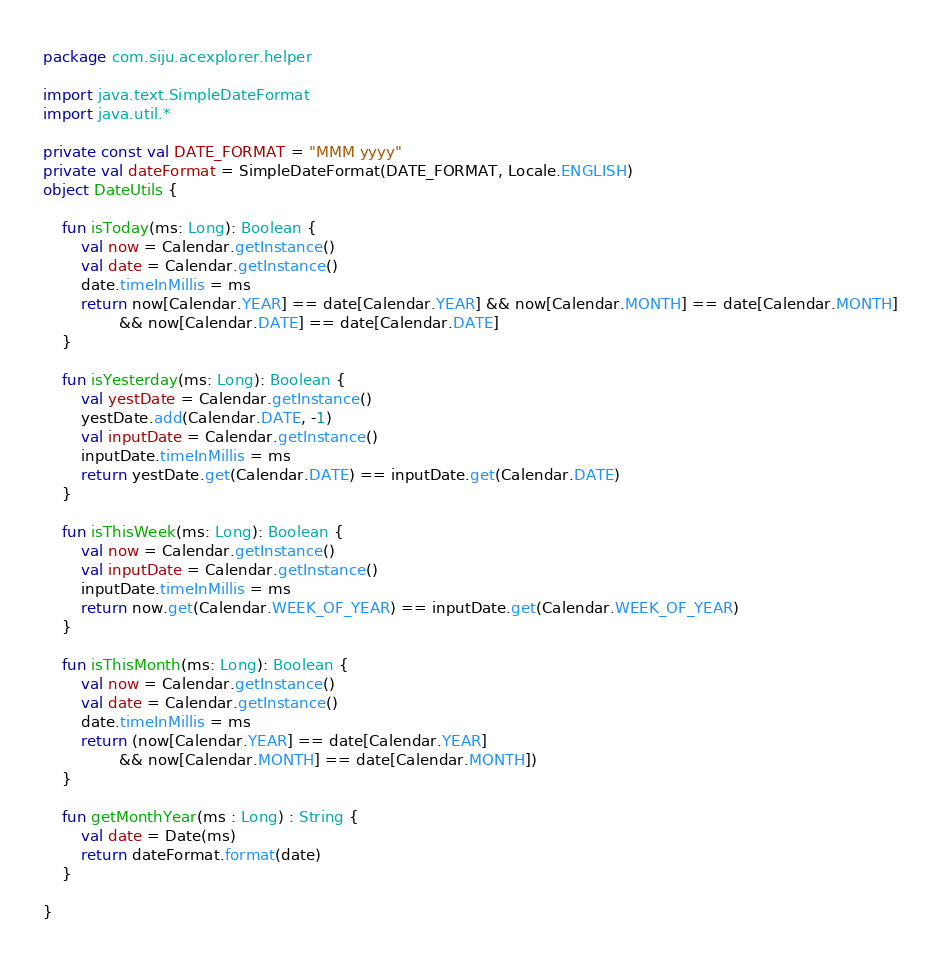<code> <loc_0><loc_0><loc_500><loc_500><_Kotlin_>package com.siju.acexplorer.helper

import java.text.SimpleDateFormat
import java.util.*

private const val DATE_FORMAT = "MMM yyyy"
private val dateFormat = SimpleDateFormat(DATE_FORMAT, Locale.ENGLISH)
object DateUtils {

    fun isToday(ms: Long): Boolean {
        val now = Calendar.getInstance()
        val date = Calendar.getInstance()
        date.timeInMillis = ms
        return now[Calendar.YEAR] == date[Calendar.YEAR] && now[Calendar.MONTH] == date[Calendar.MONTH]
                && now[Calendar.DATE] == date[Calendar.DATE]
    }

    fun isYesterday(ms: Long): Boolean {
        val yestDate = Calendar.getInstance()
        yestDate.add(Calendar.DATE, -1)
        val inputDate = Calendar.getInstance()
        inputDate.timeInMillis = ms
        return yestDate.get(Calendar.DATE) == inputDate.get(Calendar.DATE)
    }

    fun isThisWeek(ms: Long): Boolean {
        val now = Calendar.getInstance()
        val inputDate = Calendar.getInstance()
        inputDate.timeInMillis = ms
        return now.get(Calendar.WEEK_OF_YEAR) == inputDate.get(Calendar.WEEK_OF_YEAR)
    }

    fun isThisMonth(ms: Long): Boolean {
        val now = Calendar.getInstance()
        val date = Calendar.getInstance()
        date.timeInMillis = ms
        return (now[Calendar.YEAR] == date[Calendar.YEAR]
                && now[Calendar.MONTH] == date[Calendar.MONTH])
    }

    fun getMonthYear(ms : Long) : String {
        val date = Date(ms)
        return dateFormat.format(date)
    }

}</code> 